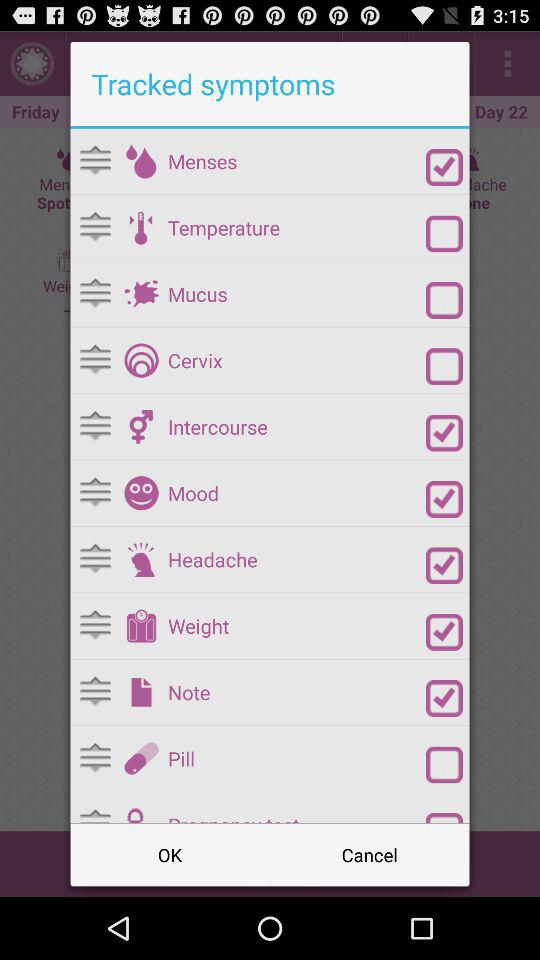Which are the selected "Tracked symptoms"? The selected "Tracked symptoms" are "Menses", "Intercourse", "Mood", "Headache", "Weight" and "Note". 